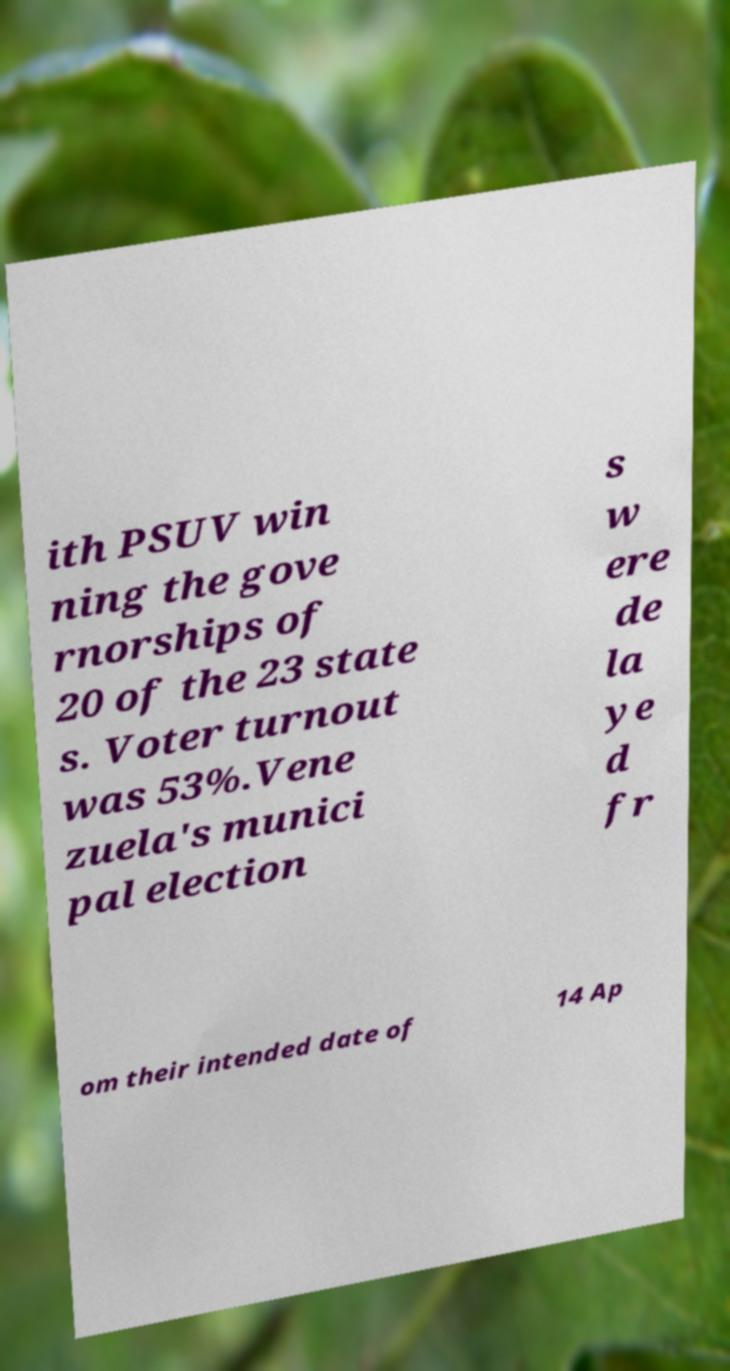Could you assist in decoding the text presented in this image and type it out clearly? ith PSUV win ning the gove rnorships of 20 of the 23 state s. Voter turnout was 53%.Vene zuela's munici pal election s w ere de la ye d fr om their intended date of 14 Ap 